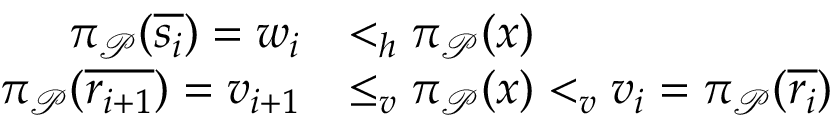<formula> <loc_0><loc_0><loc_500><loc_500>\begin{array} { r l } { \pi _ { \mathcal { P } } ( \overline { { s _ { i } } } ) = w _ { i } } & { < _ { h } \pi _ { \mathcal { P } } ( x ) } \\ { \pi _ { \mathcal { P } } ( \overline { { r _ { i + 1 } } } ) = v _ { i + 1 } } & { \leq _ { v } \pi _ { \mathcal { P } } ( x ) < _ { v } v _ { i } = \pi _ { \mathcal { P } } ( \overline { { r _ { i } } } ) } \end{array}</formula> 